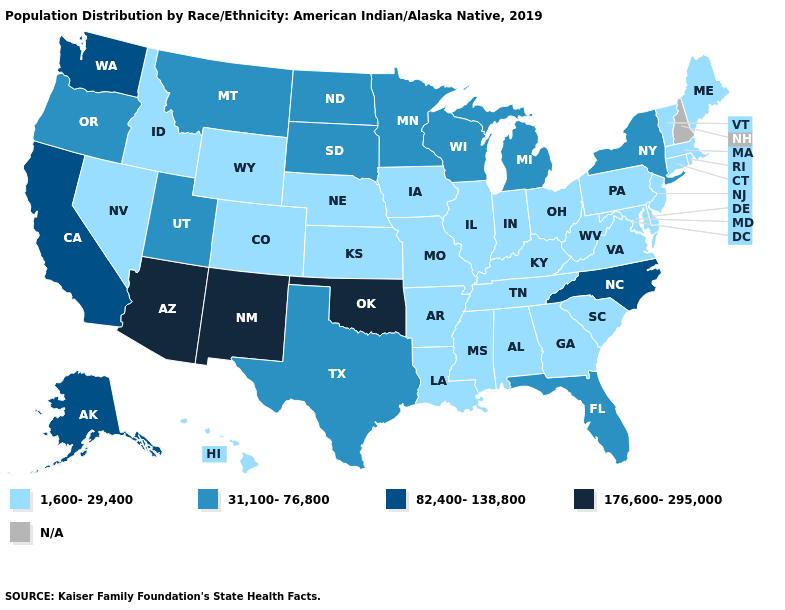Which states have the lowest value in the MidWest?
Be succinct. Illinois, Indiana, Iowa, Kansas, Missouri, Nebraska, Ohio. Name the states that have a value in the range 176,600-295,000?
Quick response, please. Arizona, New Mexico, Oklahoma. How many symbols are there in the legend?
Short answer required. 5. What is the value of Arkansas?
Give a very brief answer. 1,600-29,400. What is the lowest value in the West?
Give a very brief answer. 1,600-29,400. How many symbols are there in the legend?
Short answer required. 5. Which states have the highest value in the USA?
Short answer required. Arizona, New Mexico, Oklahoma. Name the states that have a value in the range 1,600-29,400?
Give a very brief answer. Alabama, Arkansas, Colorado, Connecticut, Delaware, Georgia, Hawaii, Idaho, Illinois, Indiana, Iowa, Kansas, Kentucky, Louisiana, Maine, Maryland, Massachusetts, Mississippi, Missouri, Nebraska, Nevada, New Jersey, Ohio, Pennsylvania, Rhode Island, South Carolina, Tennessee, Vermont, Virginia, West Virginia, Wyoming. Name the states that have a value in the range 1,600-29,400?
Concise answer only. Alabama, Arkansas, Colorado, Connecticut, Delaware, Georgia, Hawaii, Idaho, Illinois, Indiana, Iowa, Kansas, Kentucky, Louisiana, Maine, Maryland, Massachusetts, Mississippi, Missouri, Nebraska, Nevada, New Jersey, Ohio, Pennsylvania, Rhode Island, South Carolina, Tennessee, Vermont, Virginia, West Virginia, Wyoming. Name the states that have a value in the range 176,600-295,000?
Short answer required. Arizona, New Mexico, Oklahoma. Name the states that have a value in the range 82,400-138,800?
Concise answer only. Alaska, California, North Carolina, Washington. Among the states that border Arkansas , does Oklahoma have the highest value?
Keep it brief. Yes. Does Minnesota have the highest value in the MidWest?
Short answer required. Yes. Name the states that have a value in the range 1,600-29,400?
Give a very brief answer. Alabama, Arkansas, Colorado, Connecticut, Delaware, Georgia, Hawaii, Idaho, Illinois, Indiana, Iowa, Kansas, Kentucky, Louisiana, Maine, Maryland, Massachusetts, Mississippi, Missouri, Nebraska, Nevada, New Jersey, Ohio, Pennsylvania, Rhode Island, South Carolina, Tennessee, Vermont, Virginia, West Virginia, Wyoming. 